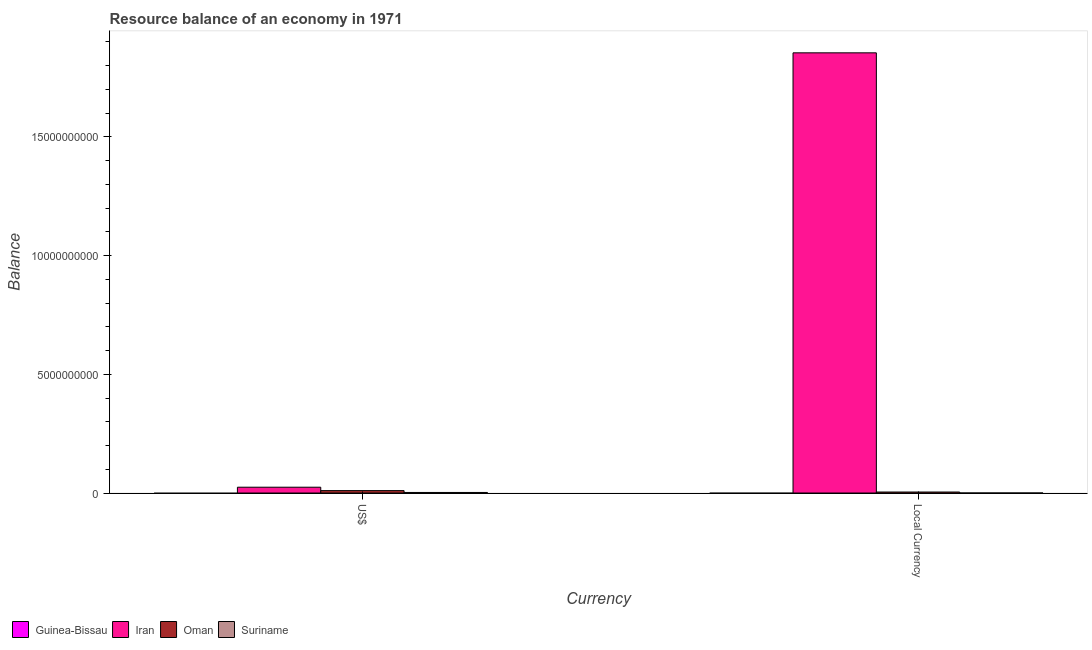How many different coloured bars are there?
Offer a very short reply. 3. How many groups of bars are there?
Your answer should be compact. 2. Are the number of bars per tick equal to the number of legend labels?
Make the answer very short. No. Are the number of bars on each tick of the X-axis equal?
Provide a short and direct response. Yes. How many bars are there on the 2nd tick from the left?
Ensure brevity in your answer.  3. How many bars are there on the 1st tick from the right?
Give a very brief answer. 3. What is the label of the 1st group of bars from the left?
Your response must be concise. US$. What is the resource balance in constant us$ in Iran?
Provide a succinct answer. 1.85e+1. Across all countries, what is the maximum resource balance in constant us$?
Provide a short and direct response. 1.85e+1. Across all countries, what is the minimum resource balance in constant us$?
Provide a succinct answer. 0. In which country was the resource balance in us$ maximum?
Your answer should be compact. Iran. What is the total resource balance in constant us$ in the graph?
Offer a terse response. 1.86e+1. What is the difference between the resource balance in constant us$ in Suriname and that in Oman?
Make the answer very short. -4.21e+07. What is the difference between the resource balance in constant us$ in Guinea-Bissau and the resource balance in us$ in Iran?
Your answer should be very brief. -2.45e+08. What is the average resource balance in us$ per country?
Provide a succinct answer. 9.24e+07. What is the difference between the resource balance in us$ and resource balance in constant us$ in Oman?
Ensure brevity in your answer.  5.92e+07. What is the ratio of the resource balance in constant us$ in Suriname to that in Iran?
Offer a very short reply. 2.5565776873113086e-6. In how many countries, is the resource balance in constant us$ greater than the average resource balance in constant us$ taken over all countries?
Your answer should be compact. 1. Are all the bars in the graph horizontal?
Give a very brief answer. No. Does the graph contain any zero values?
Your answer should be compact. Yes. Does the graph contain grids?
Ensure brevity in your answer.  No. How many legend labels are there?
Offer a very short reply. 4. What is the title of the graph?
Provide a succinct answer. Resource balance of an economy in 1971. Does "Thailand" appear as one of the legend labels in the graph?
Provide a succinct answer. No. What is the label or title of the X-axis?
Give a very brief answer. Currency. What is the label or title of the Y-axis?
Your answer should be very brief. Balance. What is the Balance of Iran in US$?
Your answer should be compact. 2.45e+08. What is the Balance in Oman in US$?
Your response must be concise. 1.01e+08. What is the Balance of Suriname in US$?
Your answer should be compact. 2.37e+07. What is the Balance of Iran in Local Currency?
Your answer should be very brief. 1.85e+1. What is the Balance in Oman in Local Currency?
Make the answer very short. 4.21e+07. What is the Balance of Suriname in Local Currency?
Keep it short and to the point. 4.74e+04. Across all Currency, what is the maximum Balance of Iran?
Provide a short and direct response. 1.85e+1. Across all Currency, what is the maximum Balance in Oman?
Give a very brief answer. 1.01e+08. Across all Currency, what is the maximum Balance in Suriname?
Provide a succinct answer. 2.37e+07. Across all Currency, what is the minimum Balance of Iran?
Make the answer very short. 2.45e+08. Across all Currency, what is the minimum Balance in Oman?
Your answer should be compact. 4.21e+07. Across all Currency, what is the minimum Balance of Suriname?
Provide a succinct answer. 4.74e+04. What is the total Balance in Guinea-Bissau in the graph?
Give a very brief answer. 0. What is the total Balance in Iran in the graph?
Keep it short and to the point. 1.88e+1. What is the total Balance in Oman in the graph?
Your answer should be compact. 1.43e+08. What is the total Balance of Suriname in the graph?
Your response must be concise. 2.37e+07. What is the difference between the Balance of Iran in US$ and that in Local Currency?
Your answer should be compact. -1.83e+1. What is the difference between the Balance of Oman in US$ and that in Local Currency?
Make the answer very short. 5.92e+07. What is the difference between the Balance in Suriname in US$ and that in Local Currency?
Your response must be concise. 2.37e+07. What is the difference between the Balance in Iran in US$ and the Balance in Oman in Local Currency?
Keep it short and to the point. 2.03e+08. What is the difference between the Balance in Iran in US$ and the Balance in Suriname in Local Currency?
Your response must be concise. 2.45e+08. What is the difference between the Balance in Oman in US$ and the Balance in Suriname in Local Currency?
Ensure brevity in your answer.  1.01e+08. What is the average Balance in Guinea-Bissau per Currency?
Offer a terse response. 0. What is the average Balance of Iran per Currency?
Offer a terse response. 9.39e+09. What is the average Balance of Oman per Currency?
Offer a very short reply. 7.17e+07. What is the average Balance of Suriname per Currency?
Give a very brief answer. 1.19e+07. What is the difference between the Balance of Iran and Balance of Oman in US$?
Keep it short and to the point. 1.43e+08. What is the difference between the Balance of Iran and Balance of Suriname in US$?
Your answer should be very brief. 2.21e+08. What is the difference between the Balance in Oman and Balance in Suriname in US$?
Your answer should be very brief. 7.76e+07. What is the difference between the Balance of Iran and Balance of Oman in Local Currency?
Make the answer very short. 1.85e+1. What is the difference between the Balance of Iran and Balance of Suriname in Local Currency?
Provide a short and direct response. 1.85e+1. What is the difference between the Balance in Oman and Balance in Suriname in Local Currency?
Ensure brevity in your answer.  4.21e+07. What is the ratio of the Balance in Iran in US$ to that in Local Currency?
Offer a very short reply. 0.01. What is the ratio of the Balance of Oman in US$ to that in Local Currency?
Make the answer very short. 2.41. What is the ratio of the Balance of Suriname in US$ to that in Local Currency?
Your answer should be very brief. 500. What is the difference between the highest and the second highest Balance in Iran?
Offer a terse response. 1.83e+1. What is the difference between the highest and the second highest Balance in Oman?
Provide a succinct answer. 5.92e+07. What is the difference between the highest and the second highest Balance in Suriname?
Give a very brief answer. 2.37e+07. What is the difference between the highest and the lowest Balance of Iran?
Provide a succinct answer. 1.83e+1. What is the difference between the highest and the lowest Balance in Oman?
Your response must be concise. 5.92e+07. What is the difference between the highest and the lowest Balance in Suriname?
Offer a very short reply. 2.37e+07. 